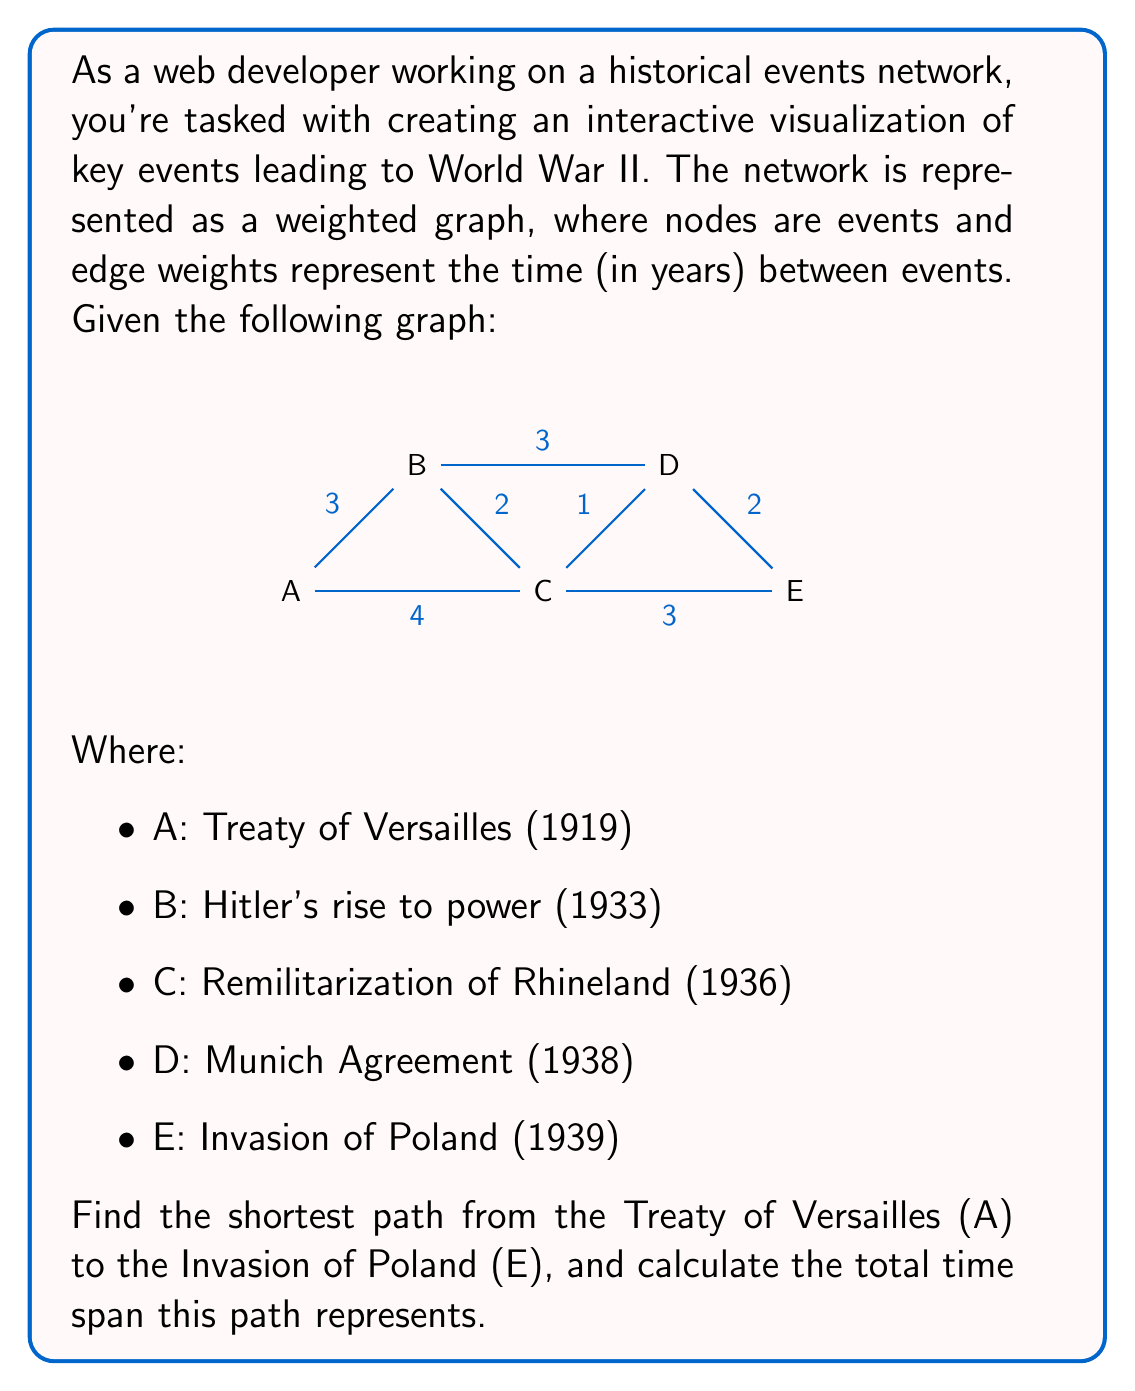Give your solution to this math problem. To solve this problem, we'll use Dijkstra's algorithm to find the shortest path from node A to node E. Here's a step-by-step explanation:

1. Initialize:
   - Set distance to A as 0, and all other nodes as infinity.
   - Set all nodes as unvisited.
   - Set A as the current node.

2. For the current node, consider all unvisited neighbors and calculate their tentative distances:
   - A to B: 3 years
   - A to C: 4 years

3. Mark A as visited. B has the smallest tentative distance (3), so make B the current node.

4. From B:
   - B to C: 3 + 2 = 5 years (shorter than current 4, so update)
   - B to D: 3 + 3 = 6 years

5. Mark B as visited. C has the smallest tentative distance (4), so make C the current node.

6. From C:
   - C to D: 4 + 1 = 5 years (shorter than current 6, so update)
   - C to E: 4 + 3 = 7 years

7. Mark C as visited. D has the smallest tentative distance (5), so make D the current node.

8. From D:
   - D to E: 5 + 2 = 7 years

9. Mark D as visited. E is the only unvisited node left, so we're done.

The shortest path is A -> C -> D -> E, with a total distance of 7 years.

To calculate the time span:
- A (Treaty of Versailles): 1919
- C (Remilitarization of Rhineland): 1936
- D (Munich Agreement): 1938
- E (Invasion of Poland): 1939

The total time span is 1939 - 1919 = 20 years.
Answer: The shortest path is A -> C -> D -> E, representing a time span of 20 years. 